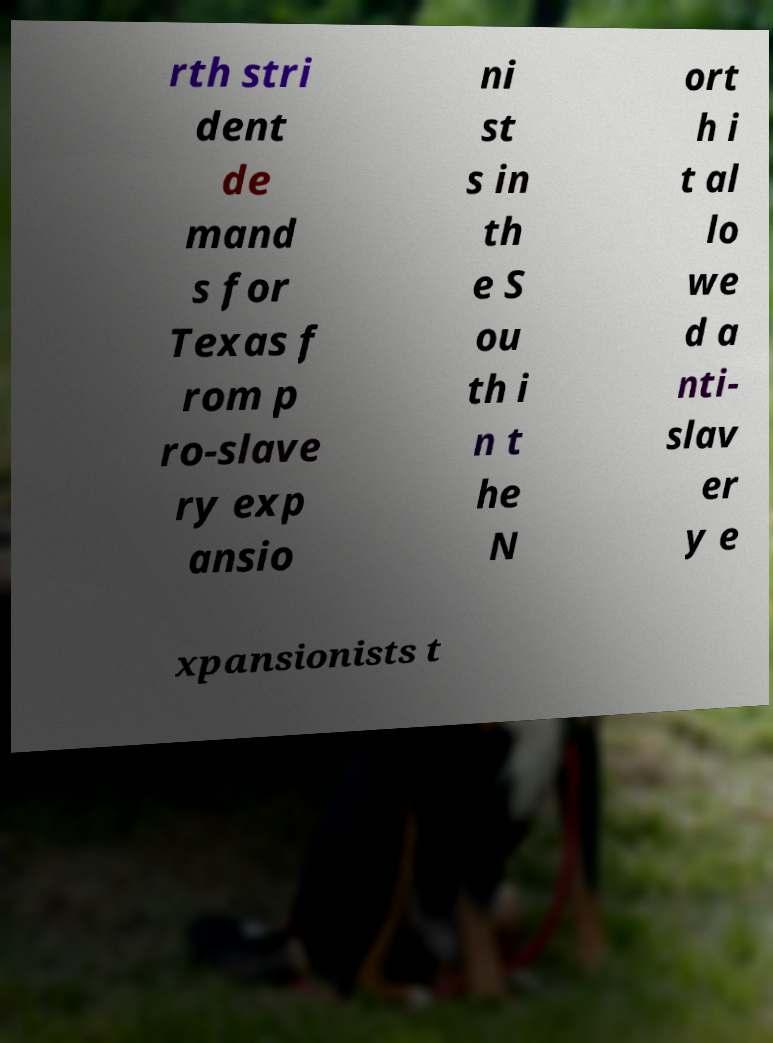Can you read and provide the text displayed in the image?This photo seems to have some interesting text. Can you extract and type it out for me? rth stri dent de mand s for Texas f rom p ro-slave ry exp ansio ni st s in th e S ou th i n t he N ort h i t al lo we d a nti- slav er y e xpansionists t 